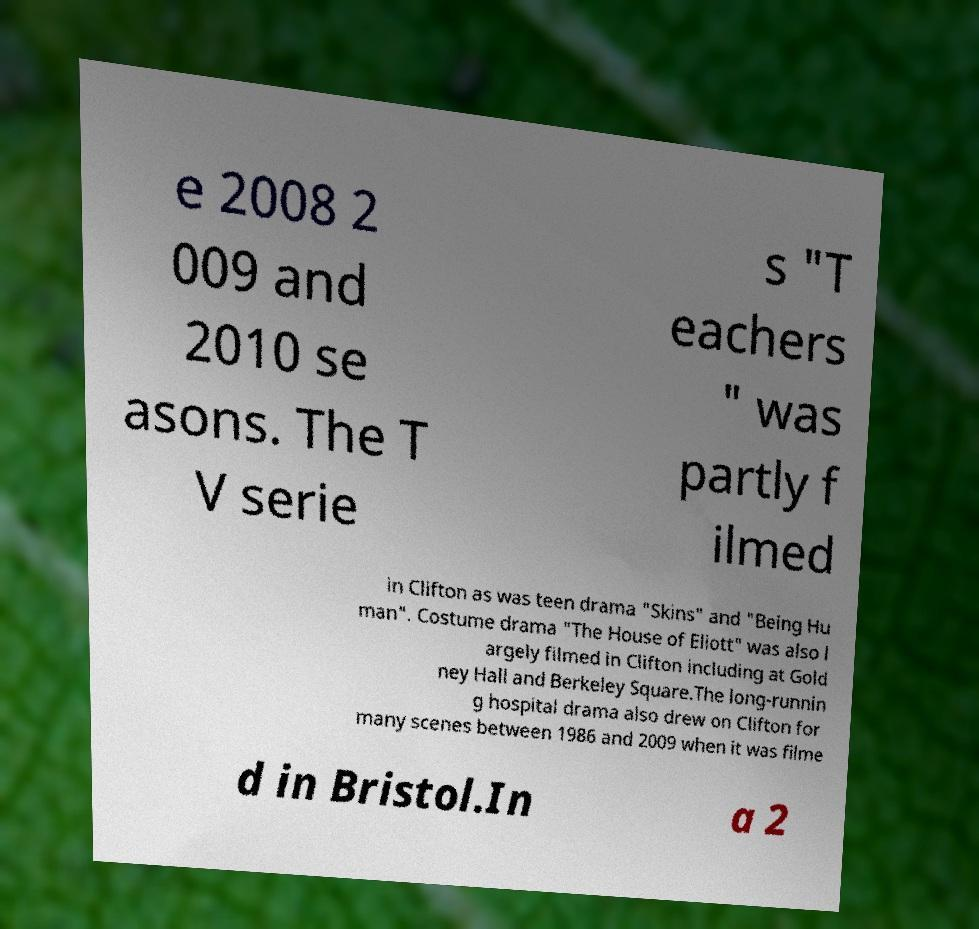Could you extract and type out the text from this image? e 2008 2 009 and 2010 se asons. The T V serie s "T eachers " was partly f ilmed in Clifton as was teen drama "Skins" and "Being Hu man". Costume drama "The House of Eliott" was also l argely filmed in Clifton including at Gold ney Hall and Berkeley Square.The long-runnin g hospital drama also drew on Clifton for many scenes between 1986 and 2009 when it was filme d in Bristol.In a 2 